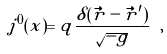Convert formula to latex. <formula><loc_0><loc_0><loc_500><loc_500>j ^ { 0 } ( x ) = q \frac { \delta ( \vec { r } - \vec { r } ^ { \prime } ) } { \sqrt { - g } } \ ,</formula> 